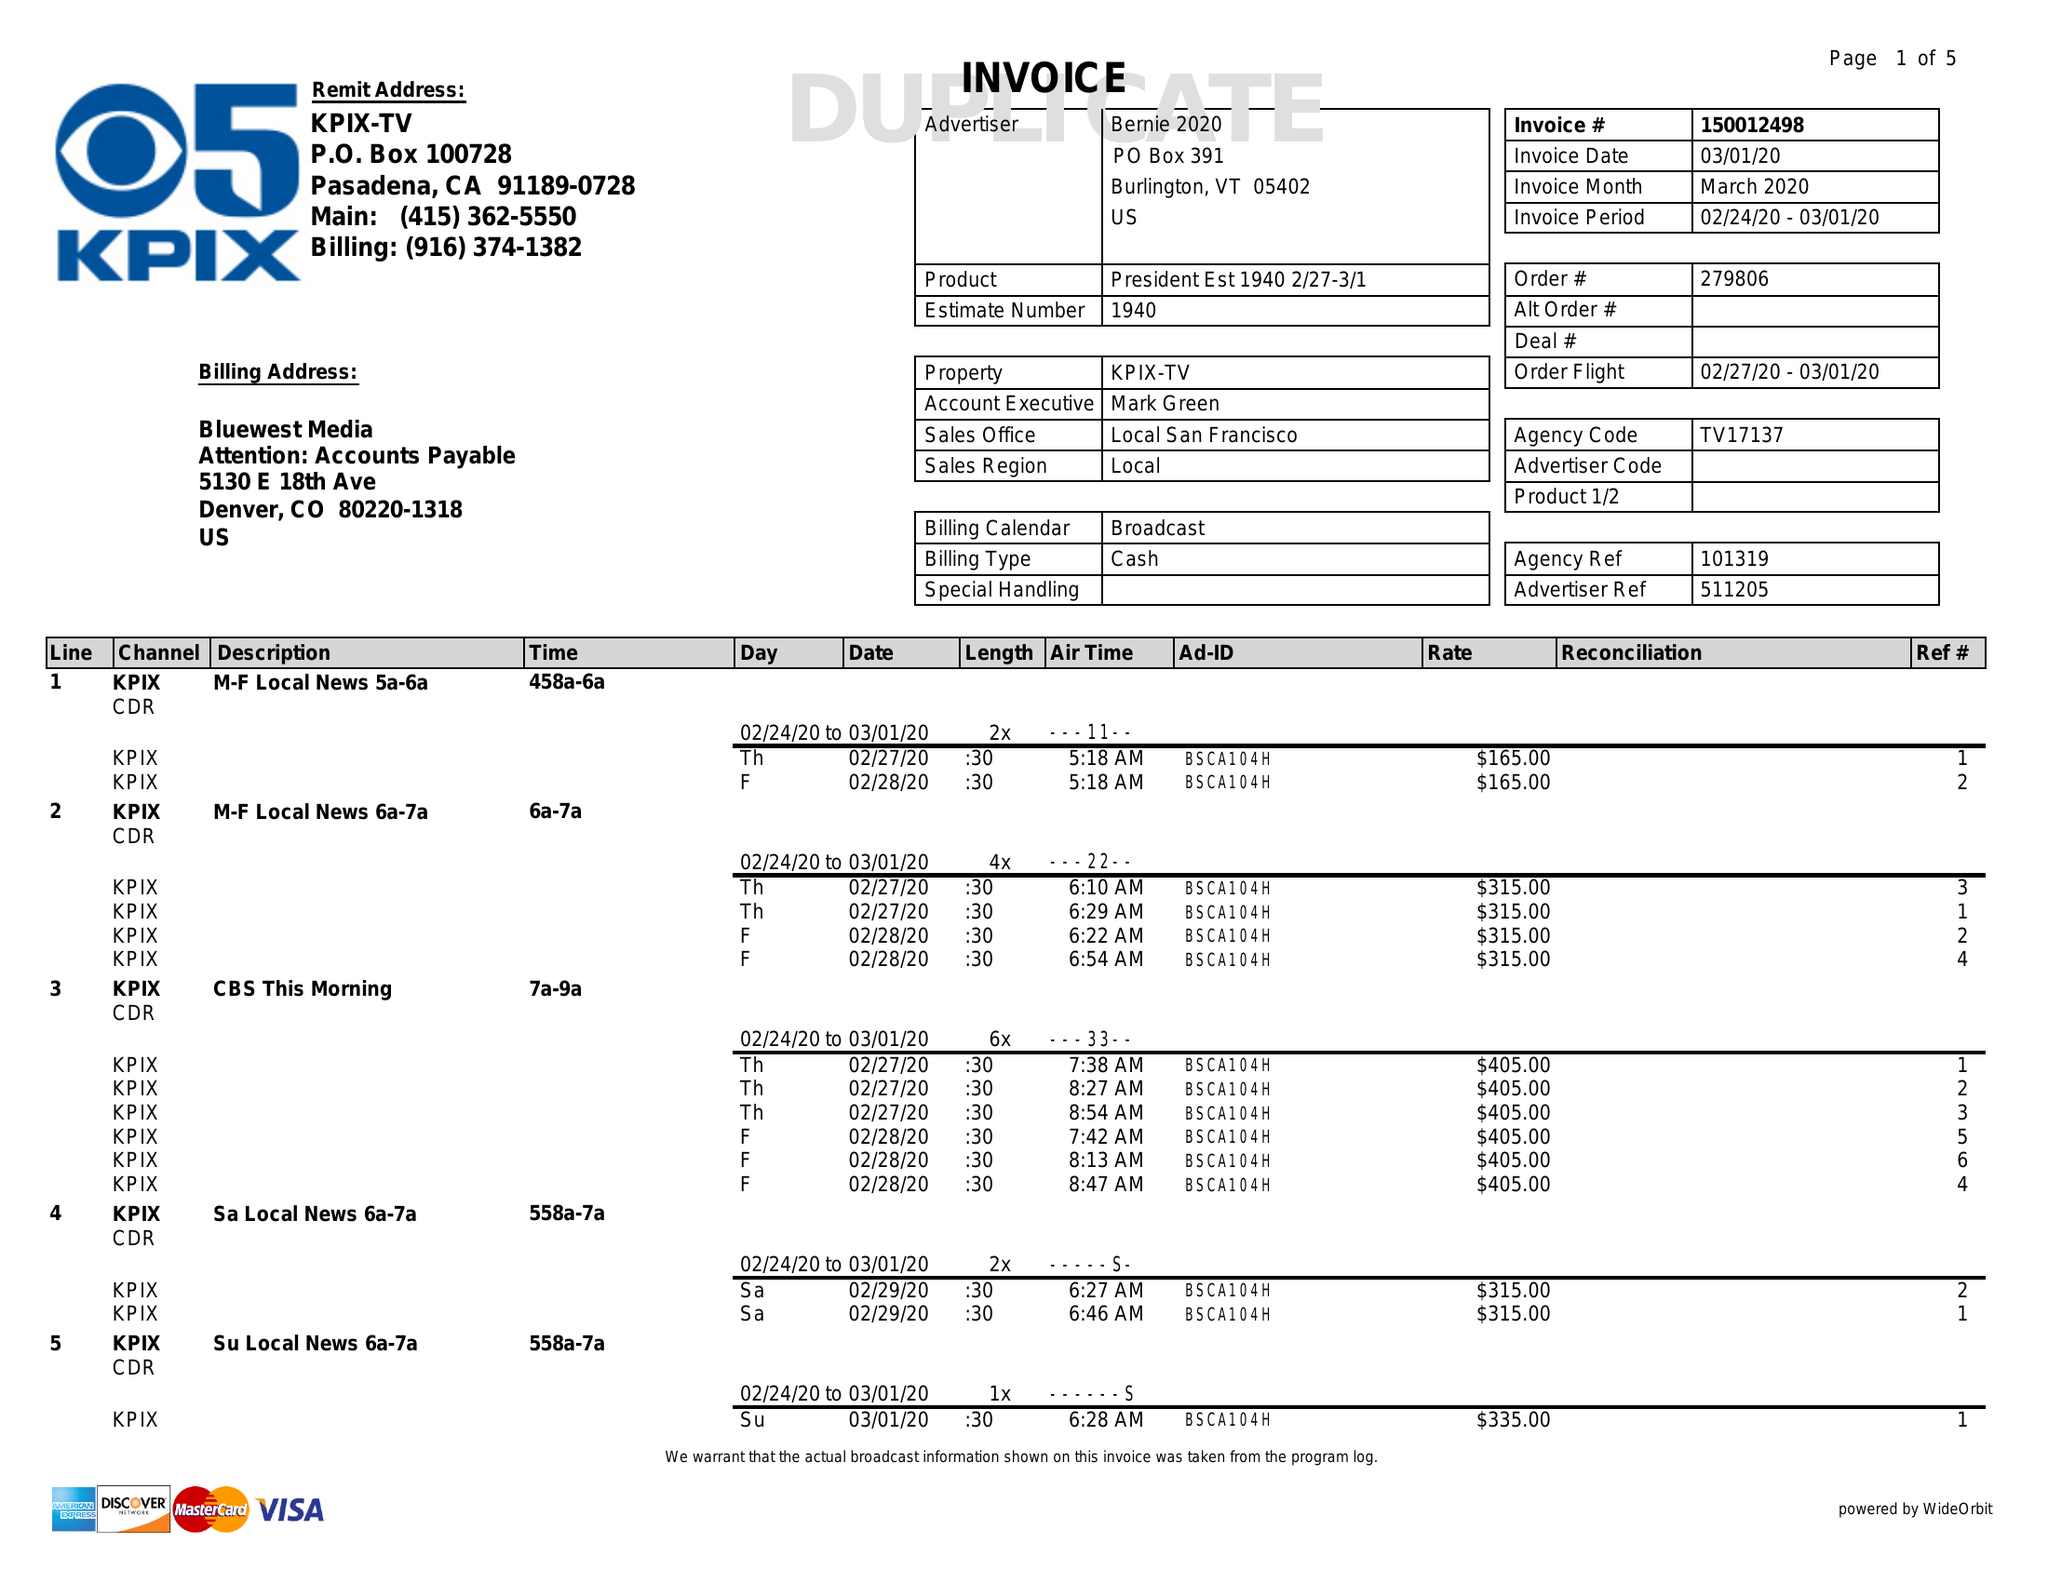What is the value for the advertiser?
Answer the question using a single word or phrase. BERNIE 2020 